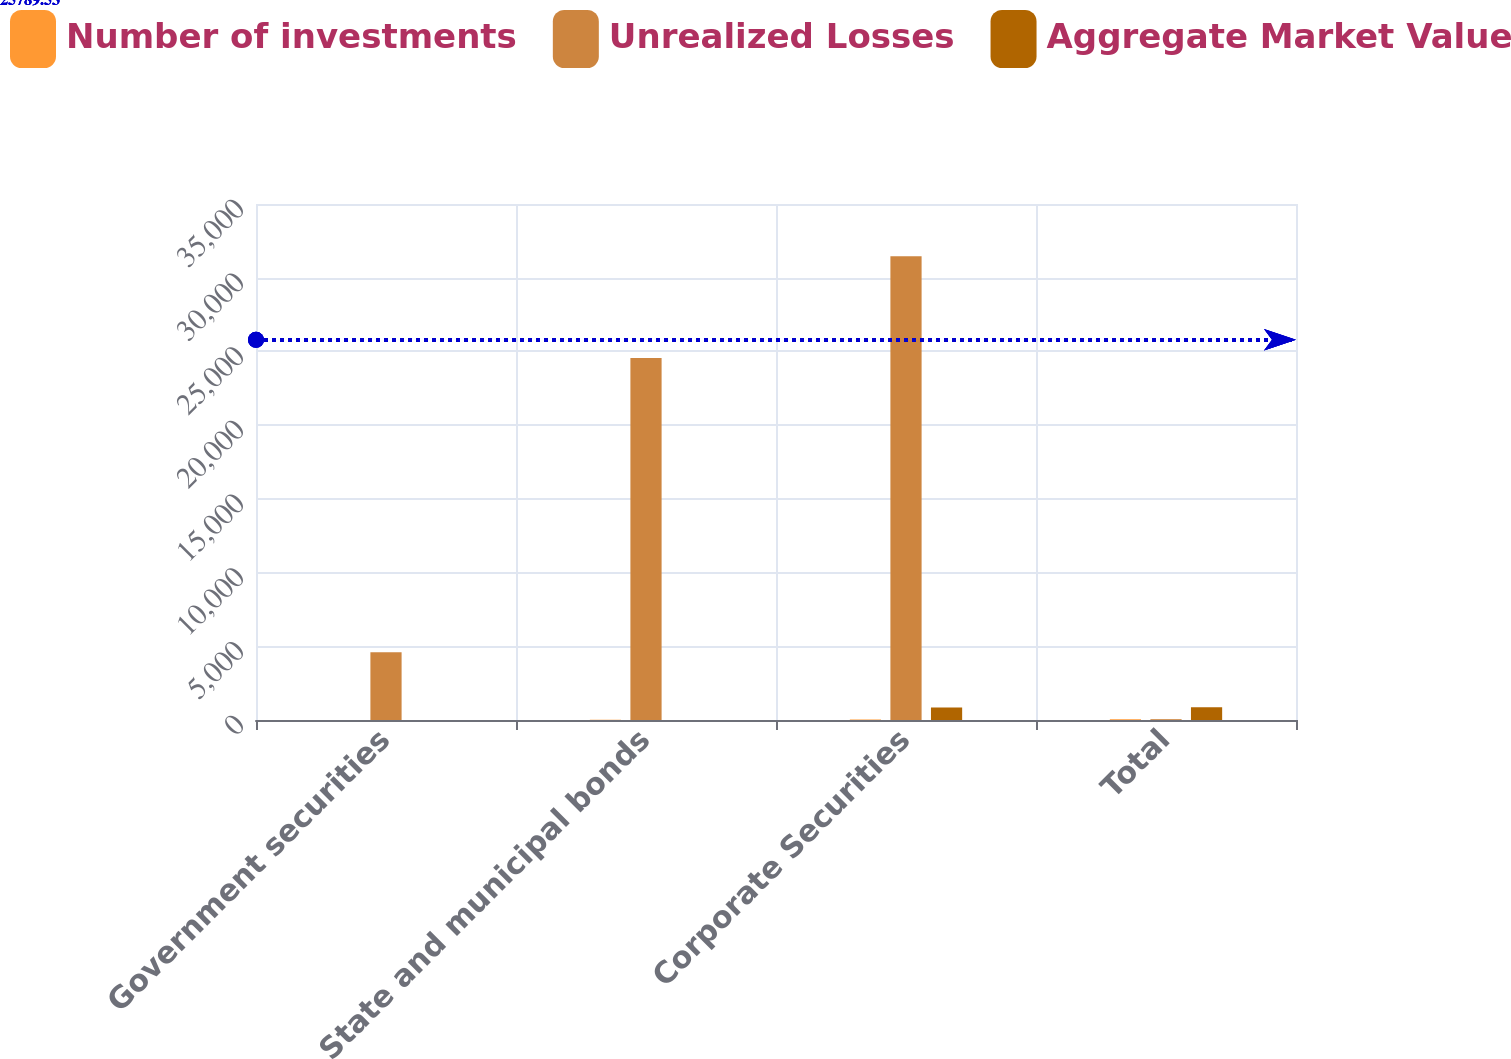Convert chart to OTSL. <chart><loc_0><loc_0><loc_500><loc_500><stacked_bar_chart><ecel><fcel>Government securities<fcel>State and municipal bonds<fcel>Corporate Securities<fcel>Total<nl><fcel>Number of investments<fcel>5<fcel>16<fcel>35<fcel>56<nl><fcel>Unrealized Losses<fcel>4599<fcel>24556<fcel>31461<fcel>56<nl><fcel>Aggregate Market Value<fcel>3<fcel>7<fcel>855<fcel>865<nl></chart> 